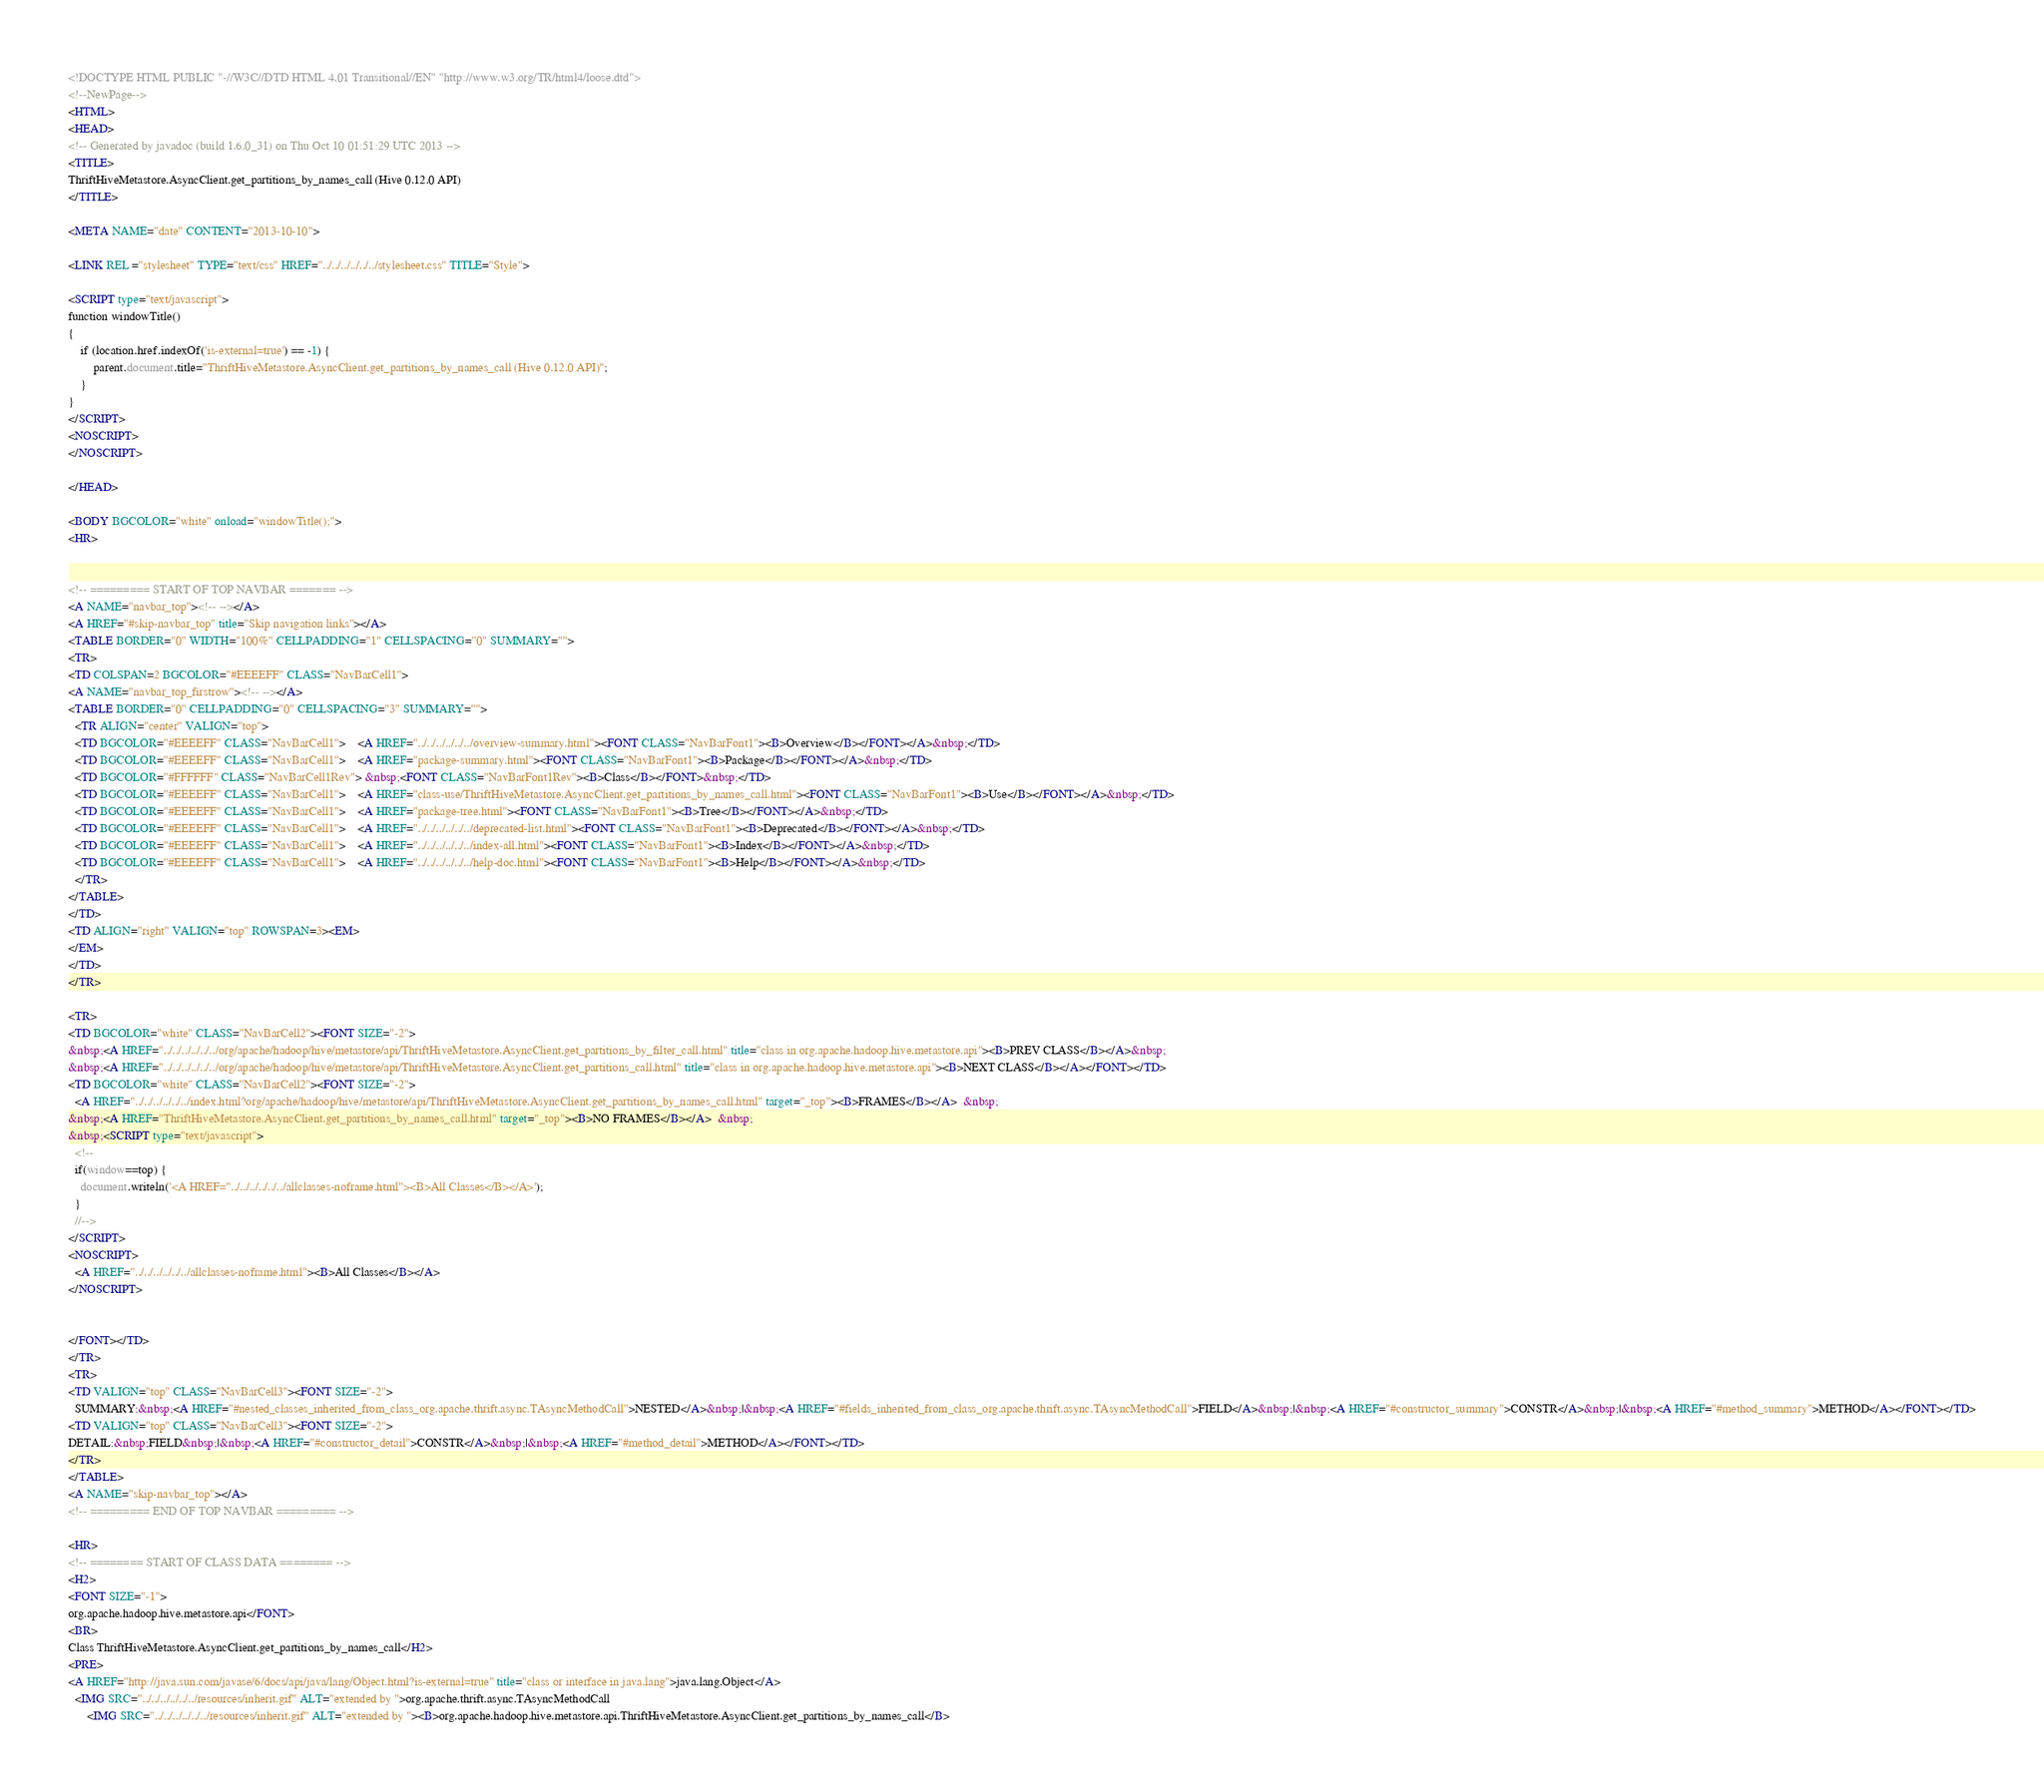Convert code to text. <code><loc_0><loc_0><loc_500><loc_500><_HTML_><!DOCTYPE HTML PUBLIC "-//W3C//DTD HTML 4.01 Transitional//EN" "http://www.w3.org/TR/html4/loose.dtd">
<!--NewPage-->
<HTML>
<HEAD>
<!-- Generated by javadoc (build 1.6.0_31) on Thu Oct 10 01:51:29 UTC 2013 -->
<TITLE>
ThriftHiveMetastore.AsyncClient.get_partitions_by_names_call (Hive 0.12.0 API)
</TITLE>

<META NAME="date" CONTENT="2013-10-10">

<LINK REL ="stylesheet" TYPE="text/css" HREF="../../../../../../stylesheet.css" TITLE="Style">

<SCRIPT type="text/javascript">
function windowTitle()
{
    if (location.href.indexOf('is-external=true') == -1) {
        parent.document.title="ThriftHiveMetastore.AsyncClient.get_partitions_by_names_call (Hive 0.12.0 API)";
    }
}
</SCRIPT>
<NOSCRIPT>
</NOSCRIPT>

</HEAD>

<BODY BGCOLOR="white" onload="windowTitle();">
<HR>


<!-- ========= START OF TOP NAVBAR ======= -->
<A NAME="navbar_top"><!-- --></A>
<A HREF="#skip-navbar_top" title="Skip navigation links"></A>
<TABLE BORDER="0" WIDTH="100%" CELLPADDING="1" CELLSPACING="0" SUMMARY="">
<TR>
<TD COLSPAN=2 BGCOLOR="#EEEEFF" CLASS="NavBarCell1">
<A NAME="navbar_top_firstrow"><!-- --></A>
<TABLE BORDER="0" CELLPADDING="0" CELLSPACING="3" SUMMARY="">
  <TR ALIGN="center" VALIGN="top">
  <TD BGCOLOR="#EEEEFF" CLASS="NavBarCell1">    <A HREF="../../../../../../overview-summary.html"><FONT CLASS="NavBarFont1"><B>Overview</B></FONT></A>&nbsp;</TD>
  <TD BGCOLOR="#EEEEFF" CLASS="NavBarCell1">    <A HREF="package-summary.html"><FONT CLASS="NavBarFont1"><B>Package</B></FONT></A>&nbsp;</TD>
  <TD BGCOLOR="#FFFFFF" CLASS="NavBarCell1Rev"> &nbsp;<FONT CLASS="NavBarFont1Rev"><B>Class</B></FONT>&nbsp;</TD>
  <TD BGCOLOR="#EEEEFF" CLASS="NavBarCell1">    <A HREF="class-use/ThriftHiveMetastore.AsyncClient.get_partitions_by_names_call.html"><FONT CLASS="NavBarFont1"><B>Use</B></FONT></A>&nbsp;</TD>
  <TD BGCOLOR="#EEEEFF" CLASS="NavBarCell1">    <A HREF="package-tree.html"><FONT CLASS="NavBarFont1"><B>Tree</B></FONT></A>&nbsp;</TD>
  <TD BGCOLOR="#EEEEFF" CLASS="NavBarCell1">    <A HREF="../../../../../../deprecated-list.html"><FONT CLASS="NavBarFont1"><B>Deprecated</B></FONT></A>&nbsp;</TD>
  <TD BGCOLOR="#EEEEFF" CLASS="NavBarCell1">    <A HREF="../../../../../../index-all.html"><FONT CLASS="NavBarFont1"><B>Index</B></FONT></A>&nbsp;</TD>
  <TD BGCOLOR="#EEEEFF" CLASS="NavBarCell1">    <A HREF="../../../../../../help-doc.html"><FONT CLASS="NavBarFont1"><B>Help</B></FONT></A>&nbsp;</TD>
  </TR>
</TABLE>
</TD>
<TD ALIGN="right" VALIGN="top" ROWSPAN=3><EM>
</EM>
</TD>
</TR>

<TR>
<TD BGCOLOR="white" CLASS="NavBarCell2"><FONT SIZE="-2">
&nbsp;<A HREF="../../../../../../org/apache/hadoop/hive/metastore/api/ThriftHiveMetastore.AsyncClient.get_partitions_by_filter_call.html" title="class in org.apache.hadoop.hive.metastore.api"><B>PREV CLASS</B></A>&nbsp;
&nbsp;<A HREF="../../../../../../org/apache/hadoop/hive/metastore/api/ThriftHiveMetastore.AsyncClient.get_partitions_call.html" title="class in org.apache.hadoop.hive.metastore.api"><B>NEXT CLASS</B></A></FONT></TD>
<TD BGCOLOR="white" CLASS="NavBarCell2"><FONT SIZE="-2">
  <A HREF="../../../../../../index.html?org/apache/hadoop/hive/metastore/api/ThriftHiveMetastore.AsyncClient.get_partitions_by_names_call.html" target="_top"><B>FRAMES</B></A>  &nbsp;
&nbsp;<A HREF="ThriftHiveMetastore.AsyncClient.get_partitions_by_names_call.html" target="_top"><B>NO FRAMES</B></A>  &nbsp;
&nbsp;<SCRIPT type="text/javascript">
  <!--
  if(window==top) {
    document.writeln('<A HREF="../../../../../../allclasses-noframe.html"><B>All Classes</B></A>');
  }
  //-->
</SCRIPT>
<NOSCRIPT>
  <A HREF="../../../../../../allclasses-noframe.html"><B>All Classes</B></A>
</NOSCRIPT>


</FONT></TD>
</TR>
<TR>
<TD VALIGN="top" CLASS="NavBarCell3"><FONT SIZE="-2">
  SUMMARY:&nbsp;<A HREF="#nested_classes_inherited_from_class_org.apache.thrift.async.TAsyncMethodCall">NESTED</A>&nbsp;|&nbsp;<A HREF="#fields_inherited_from_class_org.apache.thrift.async.TAsyncMethodCall">FIELD</A>&nbsp;|&nbsp;<A HREF="#constructor_summary">CONSTR</A>&nbsp;|&nbsp;<A HREF="#method_summary">METHOD</A></FONT></TD>
<TD VALIGN="top" CLASS="NavBarCell3"><FONT SIZE="-2">
DETAIL:&nbsp;FIELD&nbsp;|&nbsp;<A HREF="#constructor_detail">CONSTR</A>&nbsp;|&nbsp;<A HREF="#method_detail">METHOD</A></FONT></TD>
</TR>
</TABLE>
<A NAME="skip-navbar_top"></A>
<!-- ========= END OF TOP NAVBAR ========= -->

<HR>
<!-- ======== START OF CLASS DATA ======== -->
<H2>
<FONT SIZE="-1">
org.apache.hadoop.hive.metastore.api</FONT>
<BR>
Class ThriftHiveMetastore.AsyncClient.get_partitions_by_names_call</H2>
<PRE>
<A HREF="http://java.sun.com/javase/6/docs/api/java/lang/Object.html?is-external=true" title="class or interface in java.lang">java.lang.Object</A>
  <IMG SRC="../../../../../../resources/inherit.gif" ALT="extended by ">org.apache.thrift.async.TAsyncMethodCall
      <IMG SRC="../../../../../../resources/inherit.gif" ALT="extended by "><B>org.apache.hadoop.hive.metastore.api.ThriftHiveMetastore.AsyncClient.get_partitions_by_names_call</B></code> 